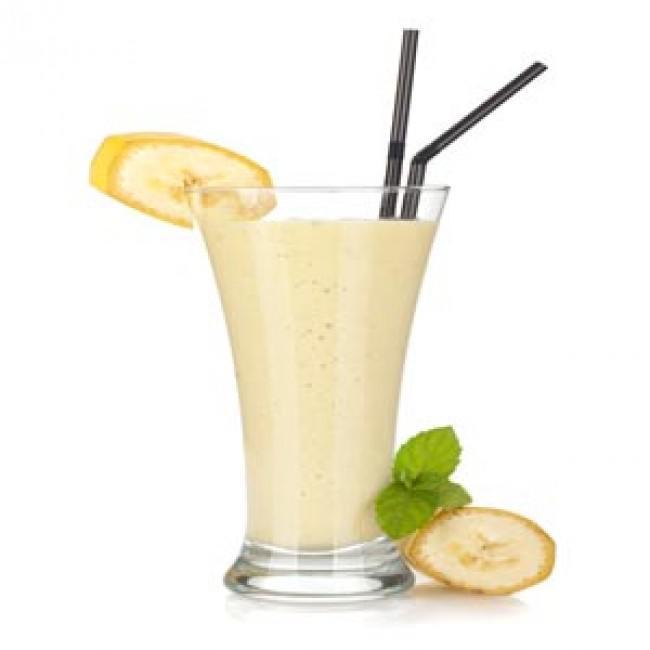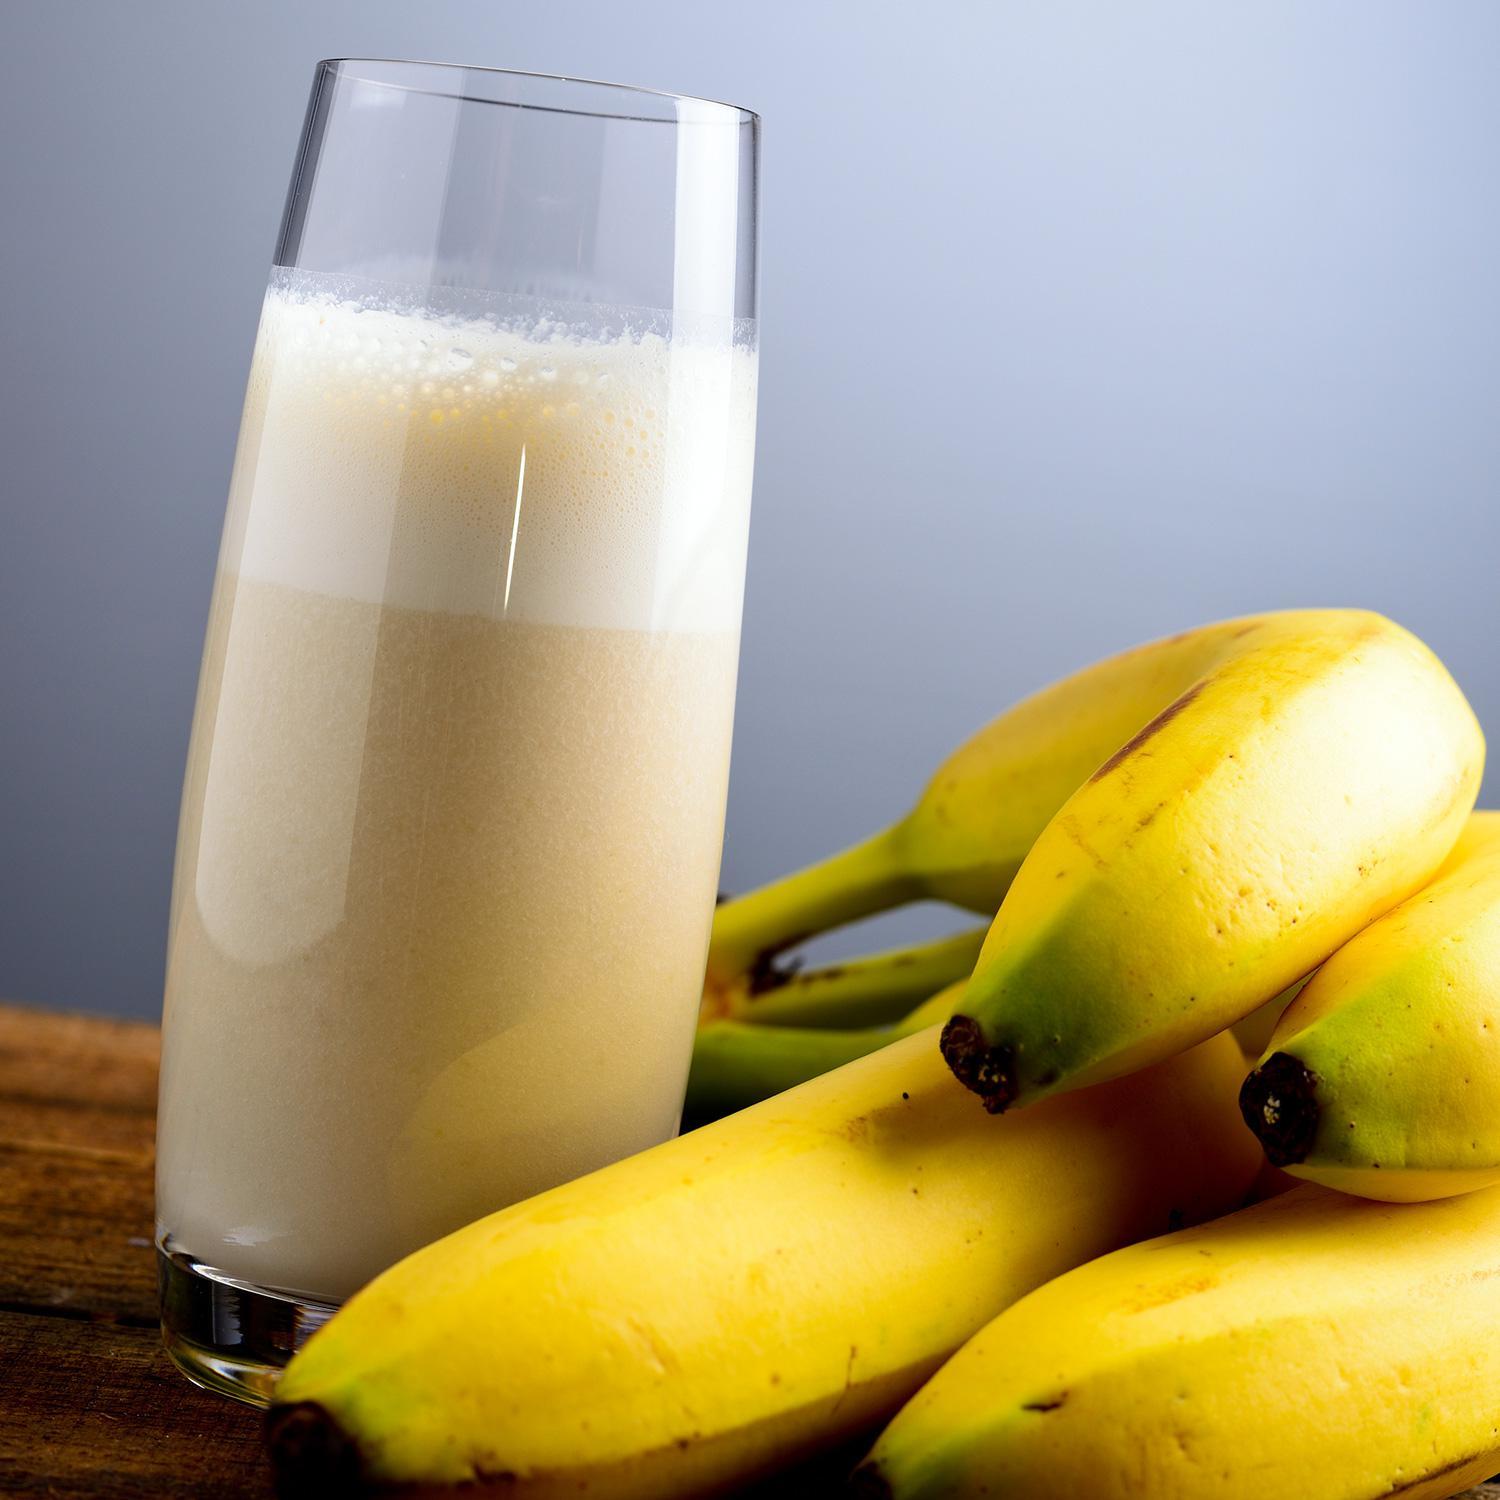The first image is the image on the left, the second image is the image on the right. Assess this claim about the two images: "Each image includes a creamy drink in a glass with a straw in it, and one image includes a slice of banana as garnish on the rim of the glass.". Correct or not? Answer yes or no. No. The first image is the image on the left, the second image is the image on the right. Analyze the images presented: Is the assertion "The right image contains a smoothie drink next to at least four bananas." valid? Answer yes or no. Yes. 